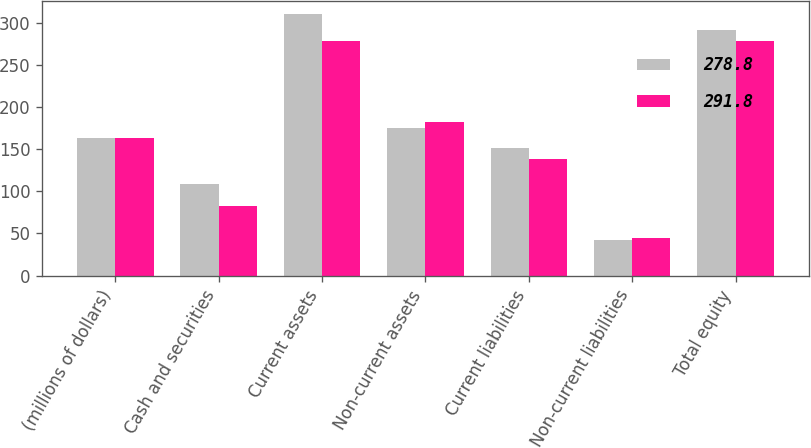Convert chart. <chart><loc_0><loc_0><loc_500><loc_500><stacked_bar_chart><ecel><fcel>(millions of dollars)<fcel>Cash and securities<fcel>Current assets<fcel>Non-current assets<fcel>Current liabilities<fcel>Non-current liabilities<fcel>Total equity<nl><fcel>278.8<fcel>163.15<fcel>109.1<fcel>310.2<fcel>174.9<fcel>151.4<fcel>41.9<fcel>291.8<nl><fcel>291.8<fcel>163.15<fcel>83<fcel>279.1<fcel>182.6<fcel>137.9<fcel>45<fcel>278.8<nl></chart> 